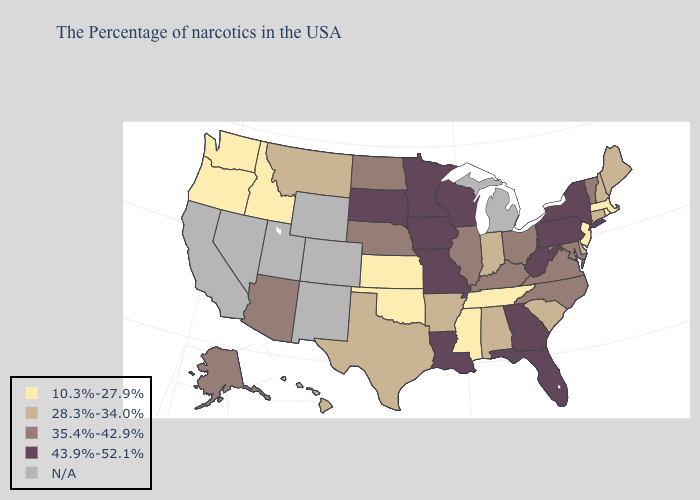What is the highest value in states that border New York?
Short answer required. 43.9%-52.1%. Does the first symbol in the legend represent the smallest category?
Concise answer only. Yes. Name the states that have a value in the range 35.4%-42.9%?
Quick response, please. Vermont, Maryland, Virginia, North Carolina, Ohio, Kentucky, Illinois, Nebraska, North Dakota, Arizona, Alaska. Name the states that have a value in the range 43.9%-52.1%?
Be succinct. New York, Pennsylvania, West Virginia, Florida, Georgia, Wisconsin, Louisiana, Missouri, Minnesota, Iowa, South Dakota. Among the states that border New Jersey , which have the lowest value?
Give a very brief answer. Delaware. What is the value of Wisconsin?
Give a very brief answer. 43.9%-52.1%. What is the value of South Carolina?
Short answer required. 28.3%-34.0%. What is the value of Oklahoma?
Keep it brief. 10.3%-27.9%. Name the states that have a value in the range 35.4%-42.9%?
Be succinct. Vermont, Maryland, Virginia, North Carolina, Ohio, Kentucky, Illinois, Nebraska, North Dakota, Arizona, Alaska. Which states hav the highest value in the South?
Write a very short answer. West Virginia, Florida, Georgia, Louisiana. Does the map have missing data?
Be succinct. Yes. 